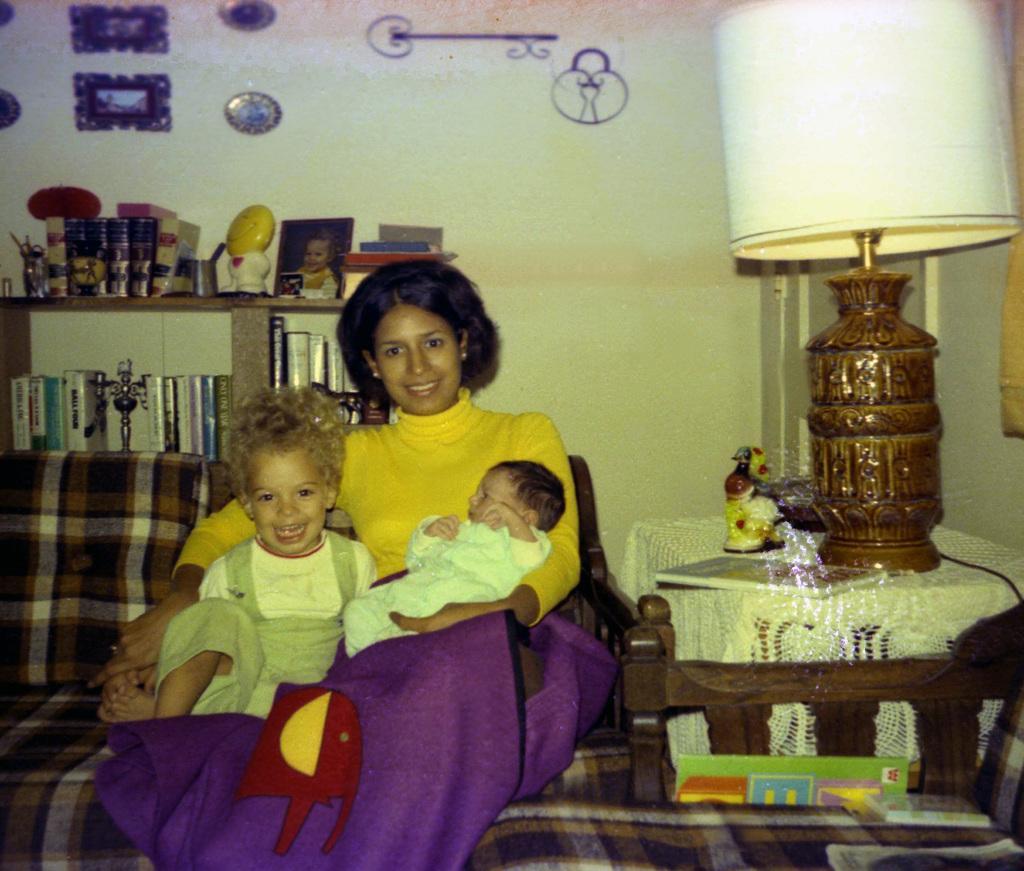Please provide a concise description of this image. A lady is holding a baby and sitting. Next to her other child is sitting. They are sitting on sofa. Beside the sofa there is a table. On the table there is a table lamp, toy and some other item. In the back there's a wall. On the wall there are some painting and there is a cupboard. On the cupboard there are books, photo frame, toys and some other things. 